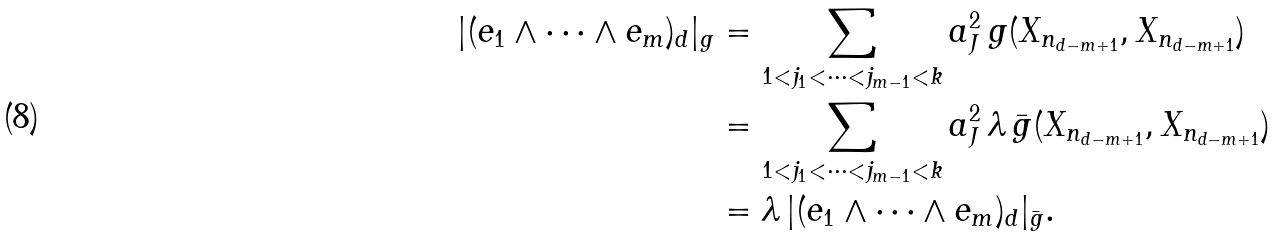<formula> <loc_0><loc_0><loc_500><loc_500>| ( e _ { 1 } \wedge \dots \wedge e _ { m } ) _ { d } | _ { g } & = \sum _ { 1 < j _ { 1 } < \cdots < j _ { m - 1 } < k } a _ { J } ^ { 2 } \, g ( X _ { n _ { d - m + 1 } } , X _ { n _ { d - m + 1 } } ) \\ & = \sum _ { 1 < j _ { 1 } < \cdots < j _ { m - 1 } < k } a _ { J } ^ { 2 } \, \lambda \, \bar { g } ( X _ { n _ { d - m + 1 } } , X _ { n _ { d - m + 1 } } ) \\ & = \lambda \, | ( e _ { 1 } \wedge \dots \wedge e _ { m } ) _ { d } | _ { \bar { g } } .</formula> 